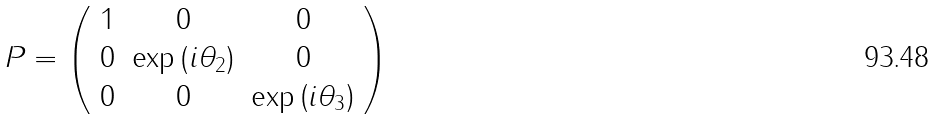<formula> <loc_0><loc_0><loc_500><loc_500>P = \left ( \begin{array} { c c c } 1 & 0 & 0 \\ 0 & \exp \left ( i \theta _ { 2 } \right ) & 0 \\ 0 & 0 & \exp \left ( i \theta _ { 3 } \right ) \end{array} \right )</formula> 